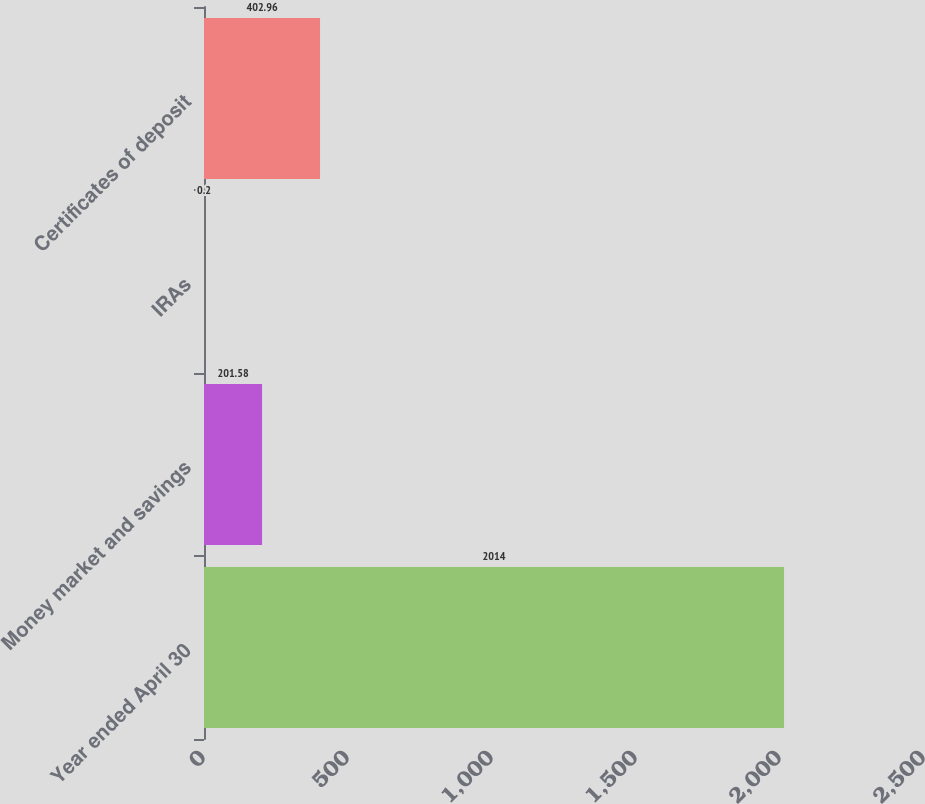Convert chart. <chart><loc_0><loc_0><loc_500><loc_500><bar_chart><fcel>Year ended April 30<fcel>Money market and savings<fcel>IRAs<fcel>Certificates of deposit<nl><fcel>2014<fcel>201.58<fcel>0.2<fcel>402.96<nl></chart> 